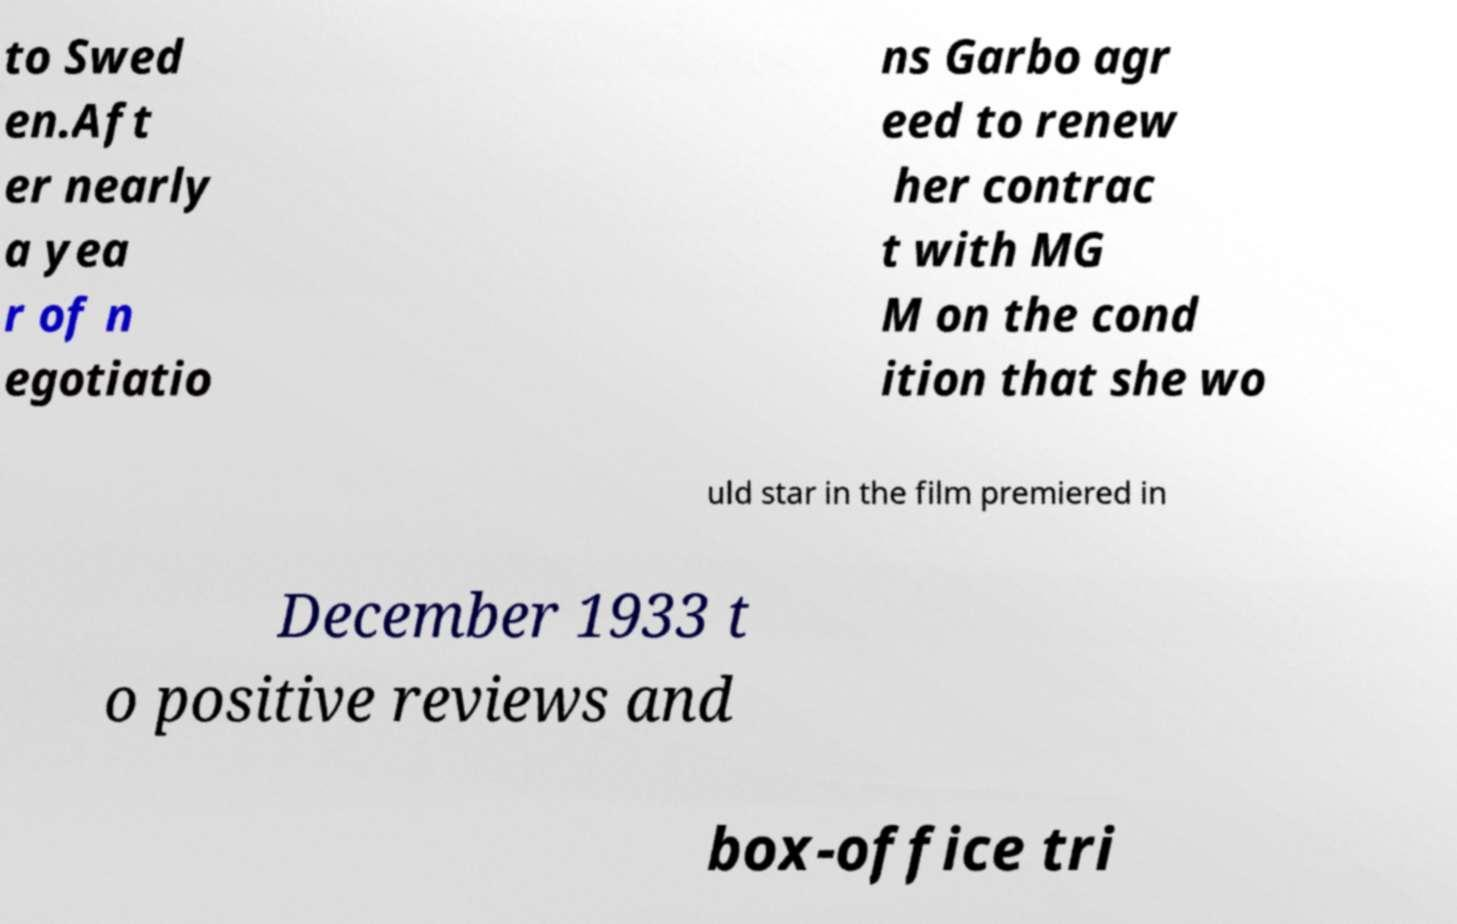There's text embedded in this image that I need extracted. Can you transcribe it verbatim? to Swed en.Aft er nearly a yea r of n egotiatio ns Garbo agr eed to renew her contrac t with MG M on the cond ition that she wo uld star in the film premiered in December 1933 t o positive reviews and box-office tri 